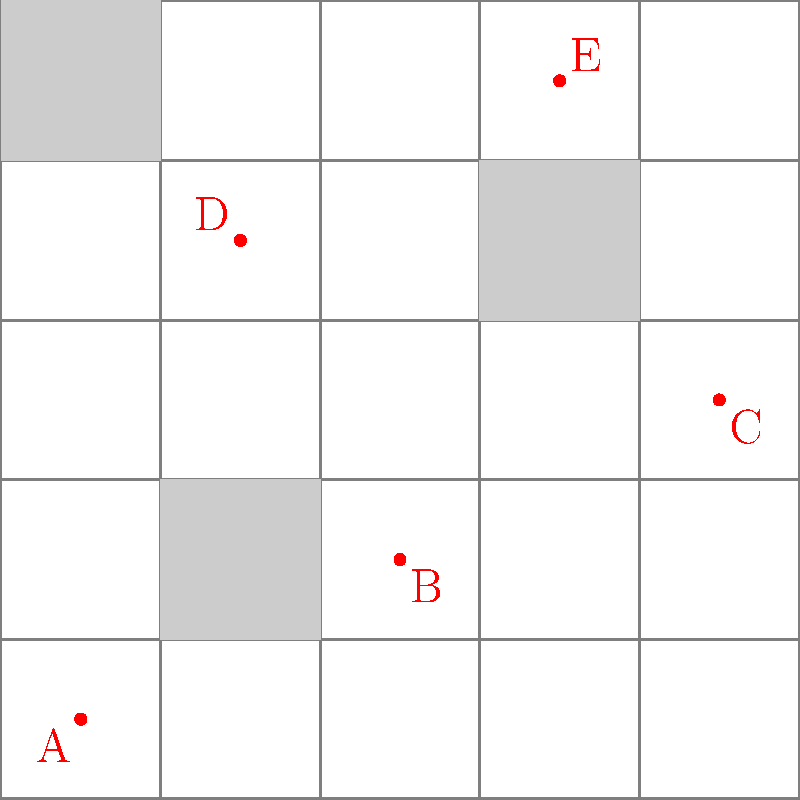In the smart city grid above, IoT sensors (represented by red dots) have been placed to optimize coverage. Which sensor placement would be most effective for monitoring traffic flow at major intersections while minimizing the number of sensors used? To determine the most effective sensor placement for monitoring traffic flow at major intersections while minimizing the number of sensors, we need to consider the following steps:

1. Identify major intersections: In a city grid, major intersections are typically located at the corners of larger blocks or where main roads intersect.

2. Analyze sensor coverage: Each sensor can typically cover a certain radius around its location, which includes multiple intersections.

3. Consider building obstructions: Sensors placed near tall buildings may have reduced coverage due to signal interference.

4. Evaluate central locations: Sensors placed more centrally can often cover multiple intersections simultaneously.

5. Minimize redundancy: Avoid placing sensors too close to each other to prevent unnecessary overlap in coverage.

Analyzing the given sensor placements:

A (0.5, 0.5): Covers the southwest corner but may have limited range due to the nearby building.
B (2.5, 1.5): Centrally located, can cover multiple intersections in the west-central area.
C (4.5, 2.5): Covers the eastern edge of the grid, but may be too far from central intersections.
D (1.5, 3.5): Well-positioned to cover the northwest quadrant and central area.
E (3.5, 4.5): Covers the northeast corner and can monitor multiple intersections in that area.

Based on this analysis, sensor B (2.5, 1.5) appears to be the most effective placement. It is centrally located, away from building obstructions, and can potentially cover the highest number of major intersections in the grid while minimizing the total number of sensors needed.
Answer: B (2.5, 1.5) 